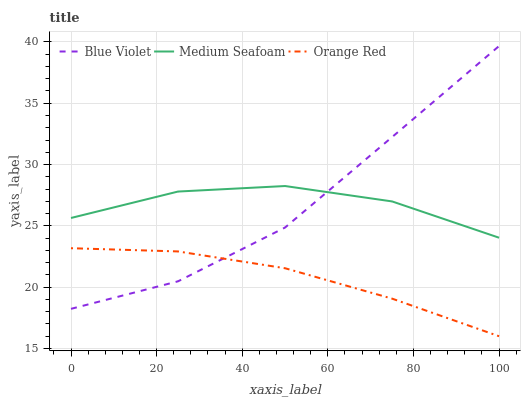Does Orange Red have the minimum area under the curve?
Answer yes or no. Yes. Does Medium Seafoam have the maximum area under the curve?
Answer yes or no. Yes. Does Blue Violet have the minimum area under the curve?
Answer yes or no. No. Does Blue Violet have the maximum area under the curve?
Answer yes or no. No. Is Orange Red the smoothest?
Answer yes or no. Yes. Is Blue Violet the roughest?
Answer yes or no. Yes. Is Blue Violet the smoothest?
Answer yes or no. No. Is Orange Red the roughest?
Answer yes or no. No. Does Orange Red have the lowest value?
Answer yes or no. Yes. Does Blue Violet have the lowest value?
Answer yes or no. No. Does Blue Violet have the highest value?
Answer yes or no. Yes. Does Orange Red have the highest value?
Answer yes or no. No. Is Orange Red less than Medium Seafoam?
Answer yes or no. Yes. Is Medium Seafoam greater than Orange Red?
Answer yes or no. Yes. Does Blue Violet intersect Orange Red?
Answer yes or no. Yes. Is Blue Violet less than Orange Red?
Answer yes or no. No. Is Blue Violet greater than Orange Red?
Answer yes or no. No. Does Orange Red intersect Medium Seafoam?
Answer yes or no. No. 